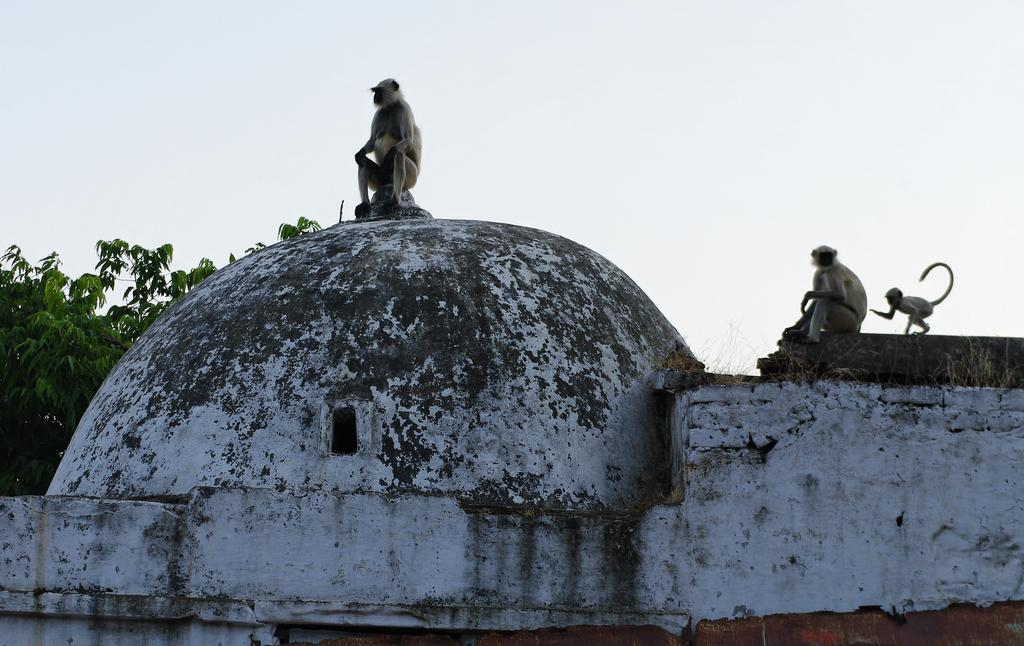What animals are in the foreground of the image? There are three monkeys in the foreground of the image. Where are the monkeys located? The monkeys are on a dome. What can be seen in the background of the image? There are trees and the sky visible in the background of the image. What type of fruit is being served on the glass table in the image? There is no fruit or glass table present in the image; it features three monkeys on a dome with trees and the sky in the background. 